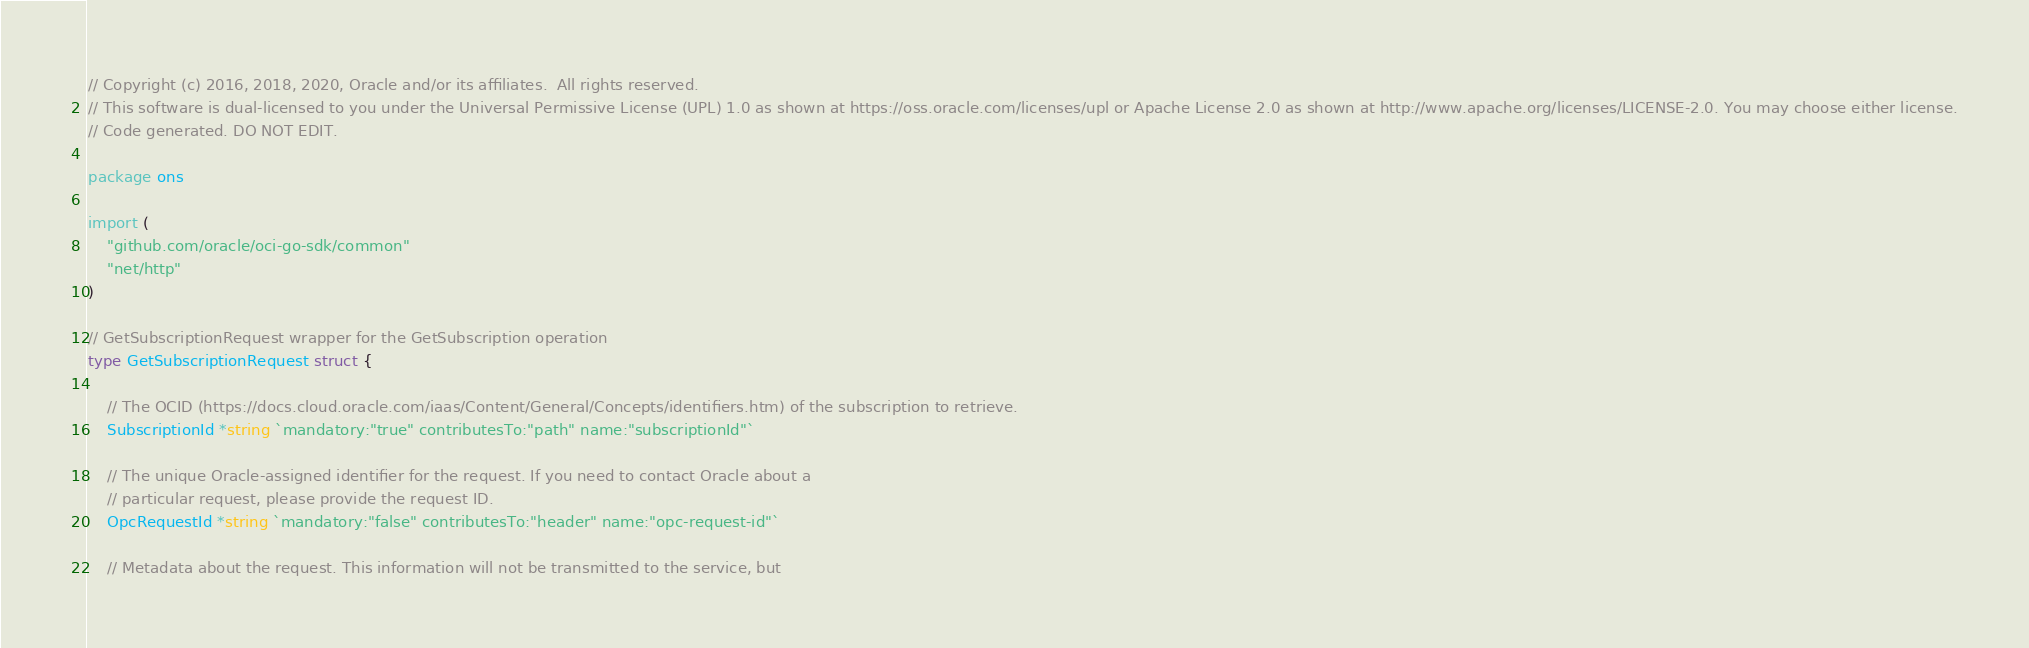<code> <loc_0><loc_0><loc_500><loc_500><_Go_>// Copyright (c) 2016, 2018, 2020, Oracle and/or its affiliates.  All rights reserved.
// This software is dual-licensed to you under the Universal Permissive License (UPL) 1.0 as shown at https://oss.oracle.com/licenses/upl or Apache License 2.0 as shown at http://www.apache.org/licenses/LICENSE-2.0. You may choose either license.
// Code generated. DO NOT EDIT.

package ons

import (
	"github.com/oracle/oci-go-sdk/common"
	"net/http"
)

// GetSubscriptionRequest wrapper for the GetSubscription operation
type GetSubscriptionRequest struct {

	// The OCID (https://docs.cloud.oracle.com/iaas/Content/General/Concepts/identifiers.htm) of the subscription to retrieve.
	SubscriptionId *string `mandatory:"true" contributesTo:"path" name:"subscriptionId"`

	// The unique Oracle-assigned identifier for the request. If you need to contact Oracle about a
	// particular request, please provide the request ID.
	OpcRequestId *string `mandatory:"false" contributesTo:"header" name:"opc-request-id"`

	// Metadata about the request. This information will not be transmitted to the service, but</code> 